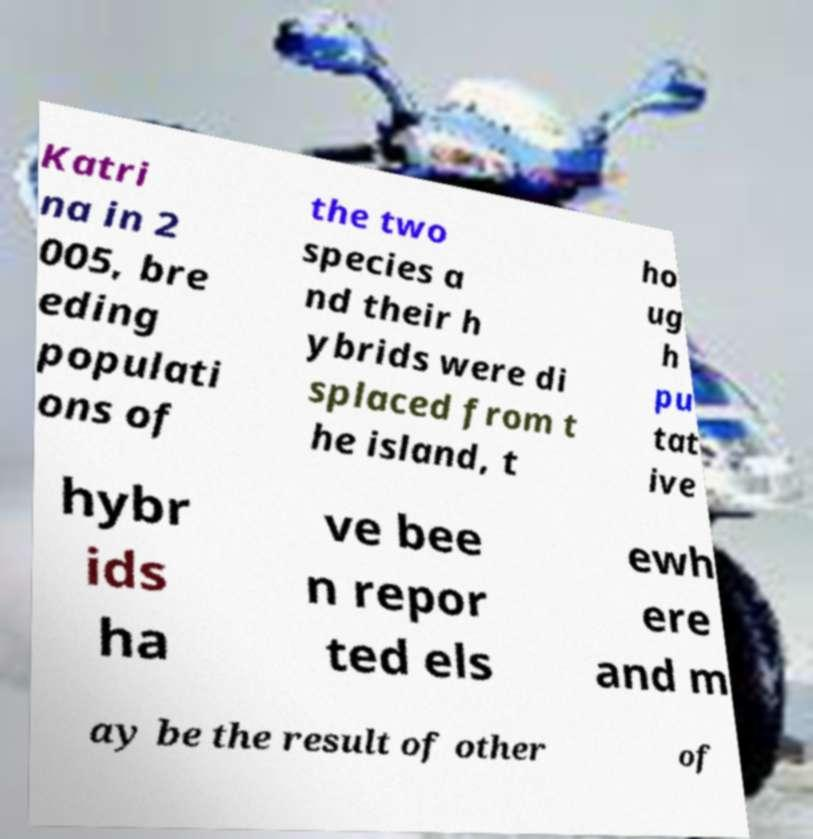I need the written content from this picture converted into text. Can you do that? Katri na in 2 005, bre eding populati ons of the two species a nd their h ybrids were di splaced from t he island, t ho ug h pu tat ive hybr ids ha ve bee n repor ted els ewh ere and m ay be the result of other of 